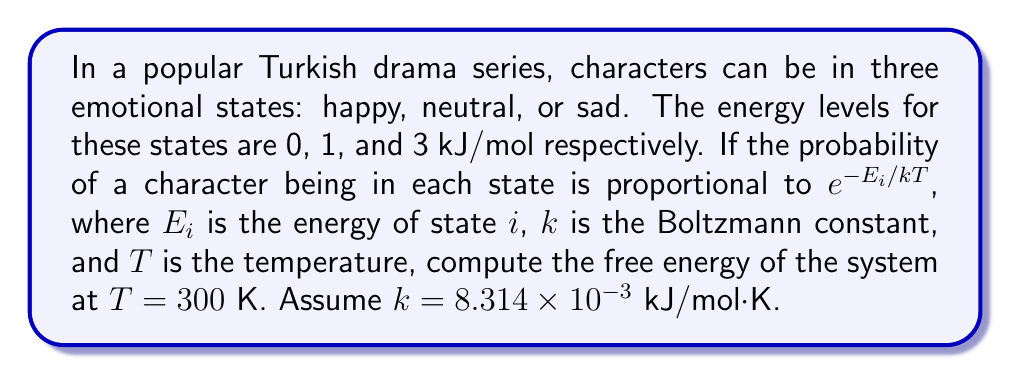Solve this math problem. Let's approach this step-by-step:

1) First, we need to calculate the partition function $Z$. The partition function is the sum of the Boltzmann factors for all states:

   $$Z = \sum_{i} e^{-E_i/kT}$$

2) We have three states with energies 0, 1, and 3 kJ/mol. Let's calculate each term:
   
   For $E_1 = 0$: $e^{-0/(8.314 \times 10^{-3} \times 300)} = 1$
   
   For $E_2 = 1$: $e^{-1/(8.314 \times 10^{-3} \times 300)} = 0.6703$
   
   For $E_3 = 3$: $e^{-3/(8.314 \times 10^{-3} \times 300)} = 0.3012$

3) Sum these to get Z:
   
   $$Z = 1 + 0.6703 + 0.3012 = 1.9715$$

4) Now, we can use the formula for free energy:

   $$F = -kT \ln Z$$

5) Plugging in our values:

   $$F = -(8.314 \times 10^{-3} \text{ kJ/mol·K})(300 \text{ K})\ln(1.9715)$$

6) Calculating:

   $$F = -2.4942 \times 0.6786 = -1.6926 \text{ kJ/mol}$$
Answer: $-1.6926$ kJ/mol 